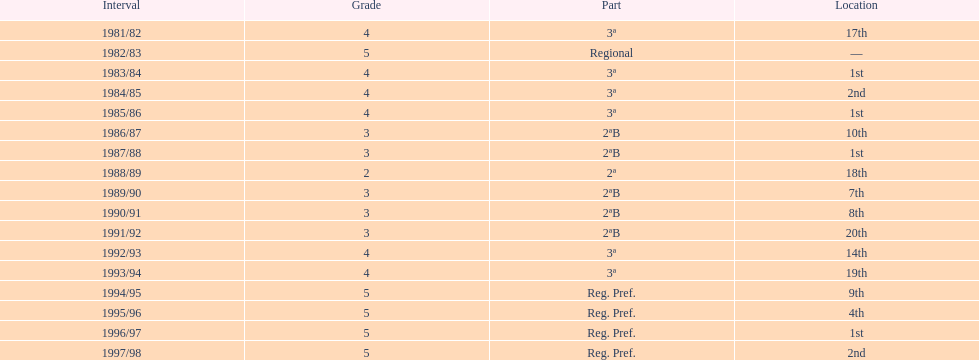When is the last year that the team has been division 2? 1991/92. 